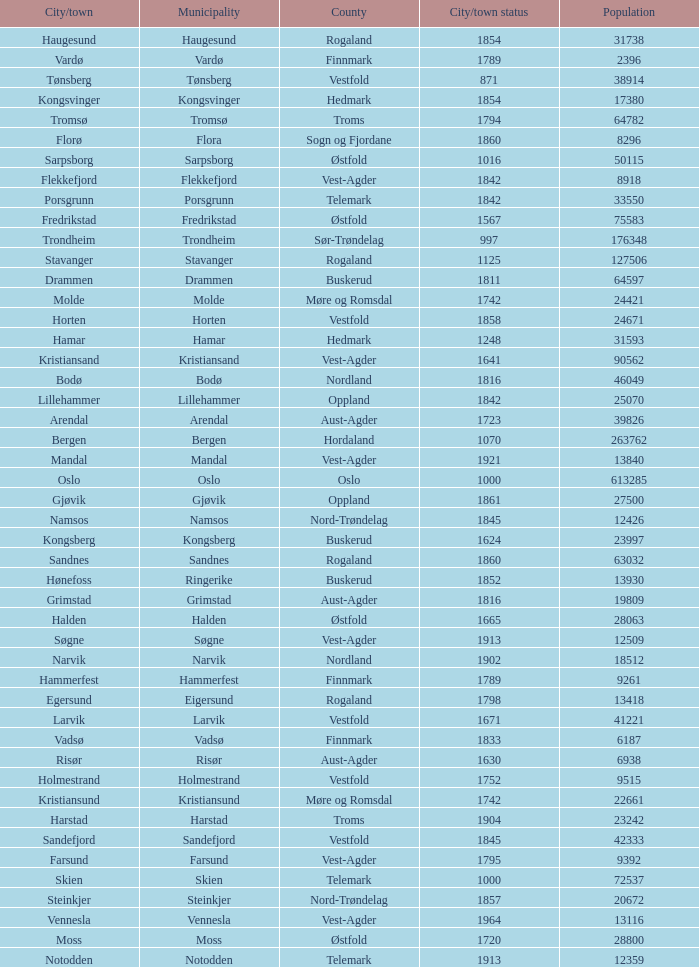Which municipalities located in the county of Finnmark have populations bigger than 6187.0? Hammerfest. 